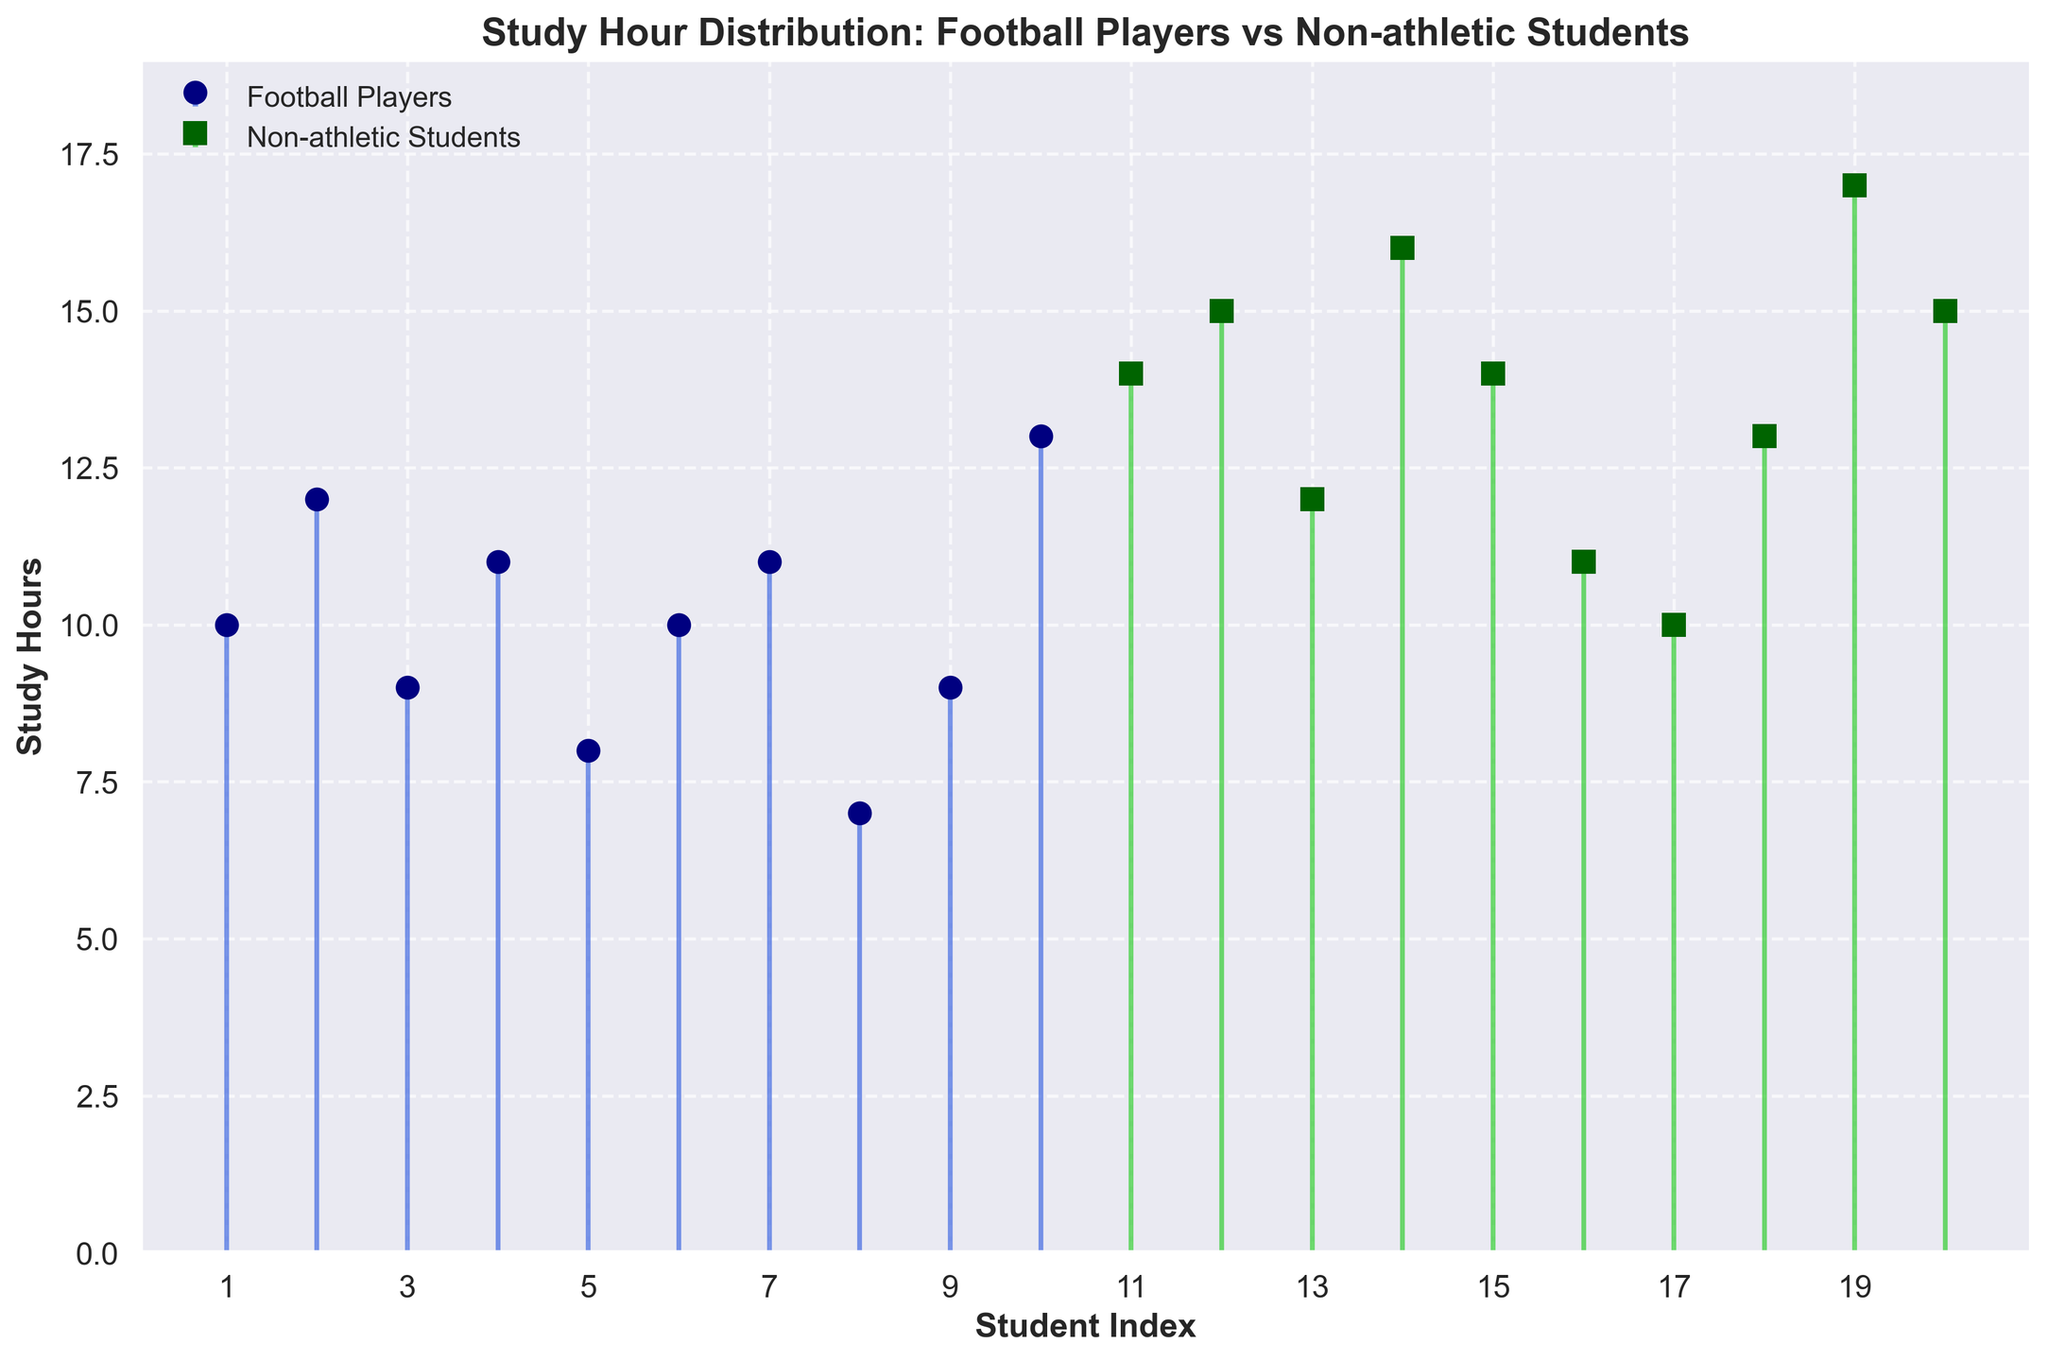How many study hours does the football player with the highest study hours have? The highest study hour among football players is represented by the tallest stem in the blue stem lines section. This value is 13, as indicated by the corresponding marker.
Answer: 13 Which group has more data points, football players or non-athletic students? By counting the number of markers in each color, there are 10 markers in the blue section for football players and 10 markers in the green section for non-athletic students. Both groups have an equal number of data points.
Answer: Both groups What is the title of the figure? The title of the figure is usually placed at the top and is written in bold. In this case, the title reads 'Study Hour Distribution: Football Players vs Non-athletic Students'.
Answer: Study Hour Distribution: Football Players vs Non-athletic Students What is the average study hours for non-athletic students? Summing the study hours for non-athletic students: 14 + 15 + 12 + 16 + 14 + 11 + 10 + 13 + 17 + 15 = 137. Dividing by the number of students (10), the average is 137 / 10.
Answer: 13.7 Which group studies more on average, football players or non-athletic students? Calculate the average study hours for both groups. Football players: (10 + 12 + 9 + 11 + 8 + 10 + 11 + 7 + 9 + 13)/10 = 10. Football players average 10 hours. Non-athletic students: (14 + 15 + 12 + 16 + 14 + 11 + 10 + 13 + 17 + 15)/10 = 13.7. Non-athletic students average 13.7 hours. Non-athletic students study more on average.
Answer: Non-athletic students What range of study hours do football players cover? Check the lowest and highest study hours for football players. The lowest is 7 and the highest is 13.
Answer: 7 to 13 Is there any overlap in study hours between football players and non-athletic students? Compare the study hours ranges for both groups. Football players range from 7 to 13, while non-athletic students range from 10 to 17. The overlapping values are from 10 to 13.
Answer: Yes What is the study hour of the 5th football player? Locate the marker for the 5th football player by counting from left to right. The 5th marker corresponds to the study hour value of 8.
Answer: 8 What is the difference in study hours between the student with the lowest number of study hours and the student with the highest number of study hours? Identify the lowest study hour (7 from a football player) and the highest study hour (17 from a non-athletic student). The difference is 17 - 7.
Answer: 10 What is the color used to represent football players? The markers and stems representing football players are in shades of blue, such as navy and royal blue.
Answer: Blue 